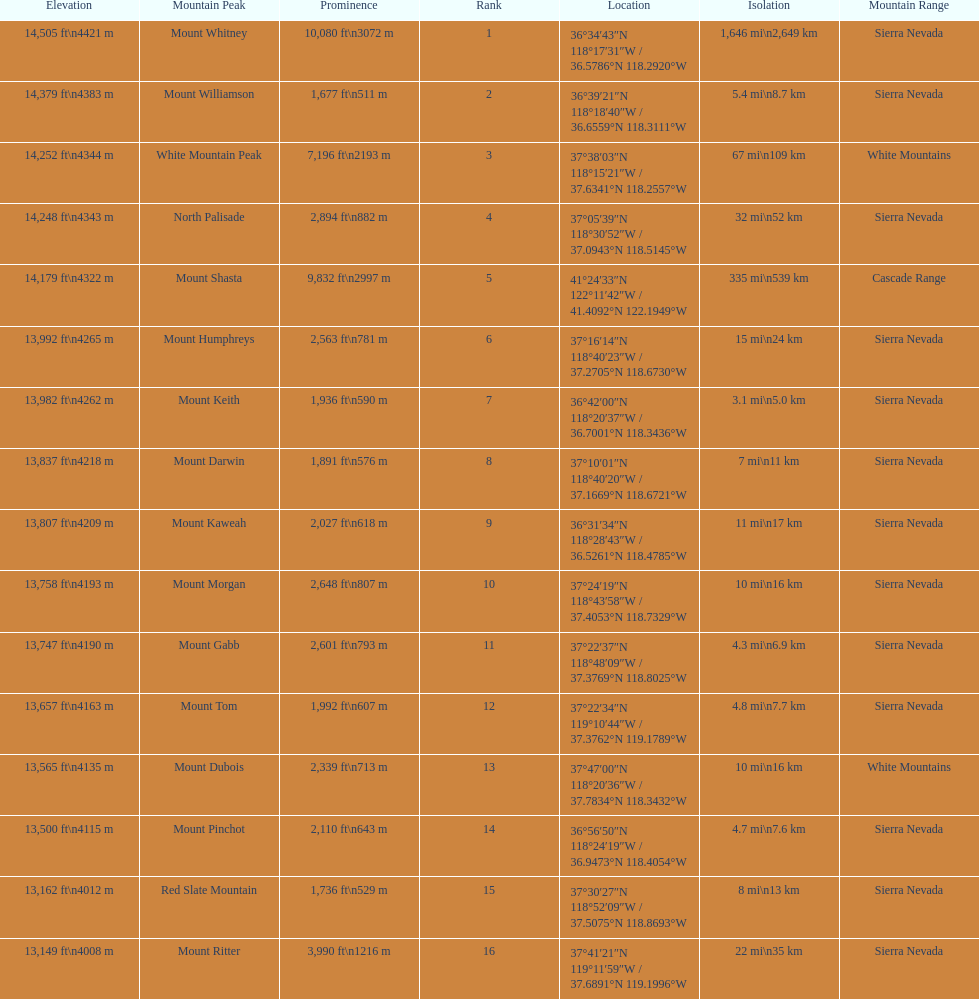What is the next highest mountain peak after north palisade? Mount Shasta. 